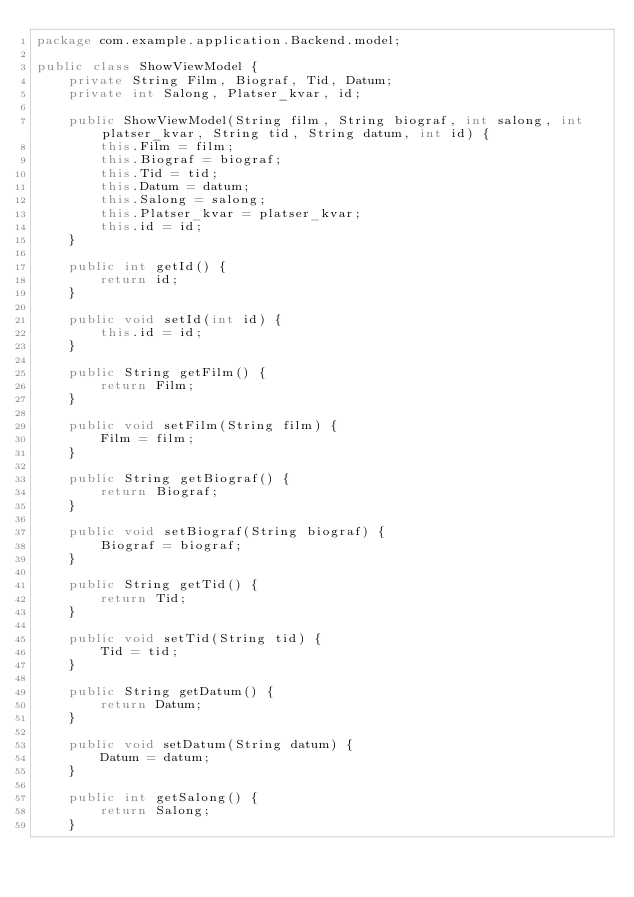<code> <loc_0><loc_0><loc_500><loc_500><_Java_>package com.example.application.Backend.model;

public class ShowViewModel {
    private String Film, Biograf, Tid, Datum;
    private int Salong, Platser_kvar, id;

    public ShowViewModel(String film, String biograf, int salong, int platser_kvar, String tid, String datum, int id) {
        this.Film = film;
        this.Biograf = biograf;
        this.Tid = tid;
        this.Datum = datum;
        this.Salong = salong;
        this.Platser_kvar = platser_kvar;
        this.id = id;
    }

    public int getId() {
        return id;
    }

    public void setId(int id) {
        this.id = id;
    }

    public String getFilm() {
        return Film;
    }

    public void setFilm(String film) {
        Film = film;
    }

    public String getBiograf() {
        return Biograf;
    }

    public void setBiograf(String biograf) {
        Biograf = biograf;
    }

    public String getTid() {
        return Tid;
    }

    public void setTid(String tid) {
        Tid = tid;
    }

    public String getDatum() {
        return Datum;
    }

    public void setDatum(String datum) {
        Datum = datum;
    }

    public int getSalong() {
        return Salong;
    }
</code> 